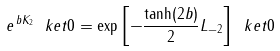Convert formula to latex. <formula><loc_0><loc_0><loc_500><loc_500>e ^ { \, b K _ { 2 } } \ k e t { 0 } = \exp \left [ - \frac { \tanh ( 2 b ) } { 2 } L _ { - 2 } \right ] \ k e t { 0 }</formula> 